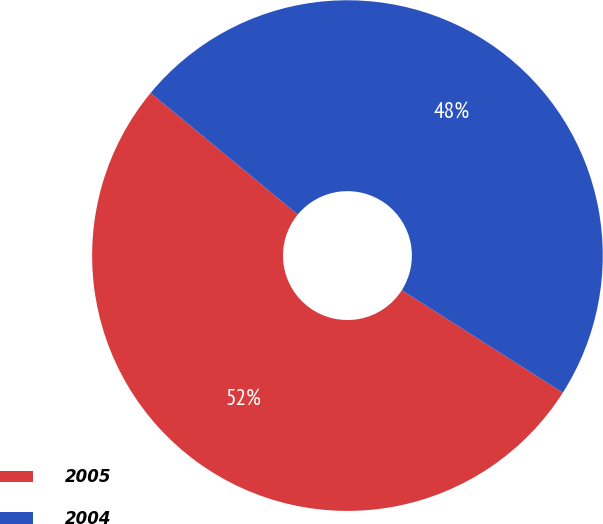<chart> <loc_0><loc_0><loc_500><loc_500><pie_chart><fcel>2005<fcel>2004<nl><fcel>51.97%<fcel>48.03%<nl></chart> 